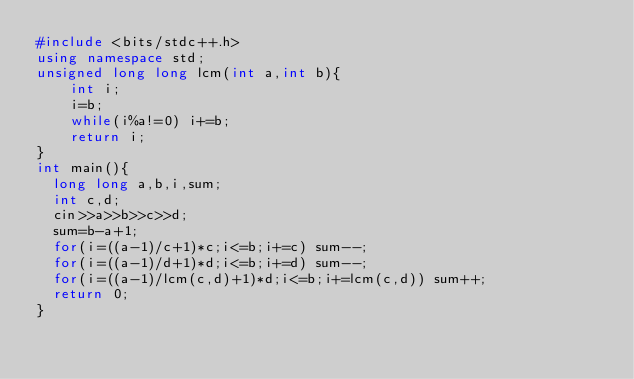<code> <loc_0><loc_0><loc_500><loc_500><_C++_>#include <bits/stdc++.h>
using namespace std;
unsigned long long lcm(int a,int b){
	int i;
	i=b;
	while(i%a!=0) i+=b;
	return i;
}
int main(){
  long long a,b,i,sum;
  int c,d;
  cin>>a>>b>>c>>d;
  sum=b-a+1;
  for(i=((a-1)/c+1)*c;i<=b;i+=c) sum--;
  for(i=((a-1)/d+1)*d;i<=b;i+=d) sum--;
  for(i=((a-1)/lcm(c,d)+1)*d;i<=b;i+=lcm(c,d)) sum++;
  return 0;
}</code> 